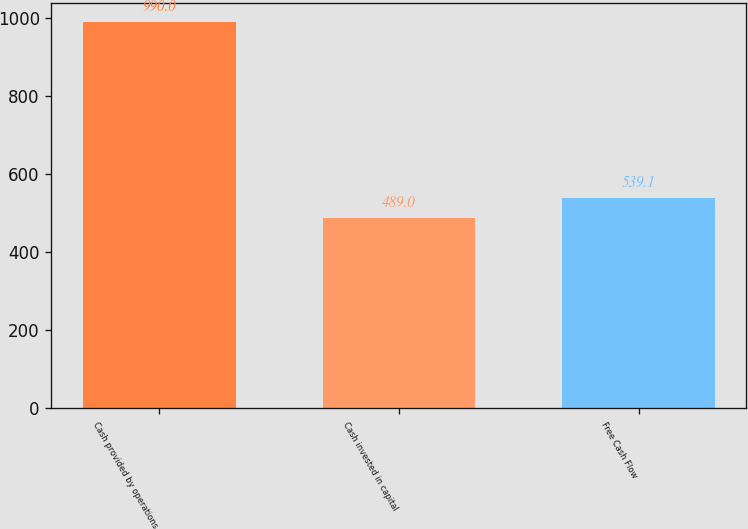<chart> <loc_0><loc_0><loc_500><loc_500><bar_chart><fcel>Cash provided by operations<fcel>Cash invested in capital<fcel>Free Cash Flow<nl><fcel>990<fcel>489<fcel>539.1<nl></chart> 